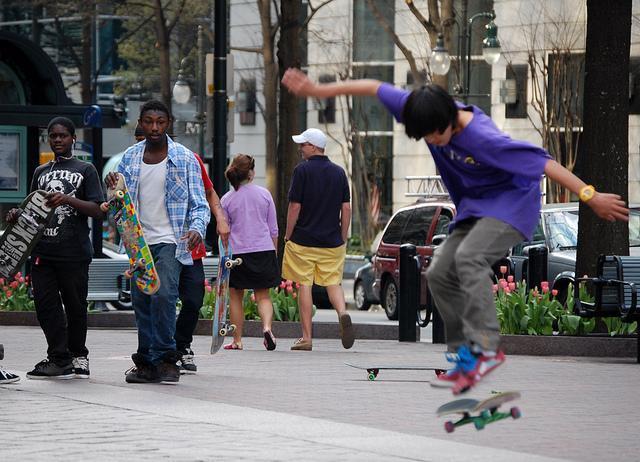How many men are touching their faces?
Give a very brief answer. 0. How many skateboards are there?
Give a very brief answer. 2. How many cars are in the photo?
Give a very brief answer. 2. How many people are in the picture?
Give a very brief answer. 6. 